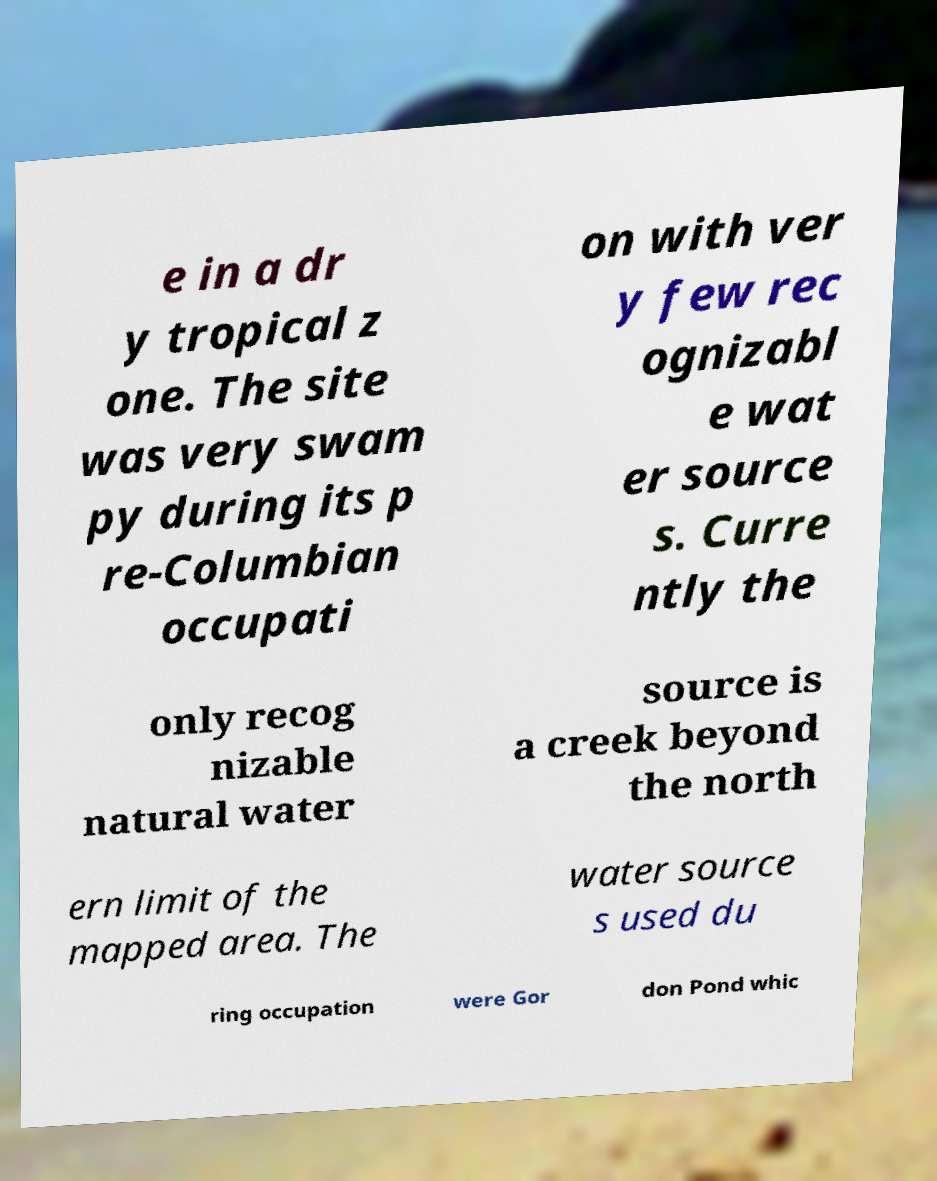Could you assist in decoding the text presented in this image and type it out clearly? e in a dr y tropical z one. The site was very swam py during its p re-Columbian occupati on with ver y few rec ognizabl e wat er source s. Curre ntly the only recog nizable natural water source is a creek beyond the north ern limit of the mapped area. The water source s used du ring occupation were Gor don Pond whic 